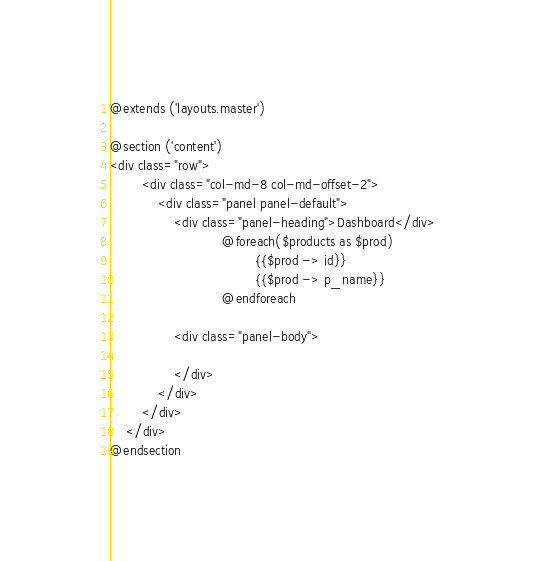Convert code to text. <code><loc_0><loc_0><loc_500><loc_500><_PHP_>@extends ('layouts.master')

@section ('content')
<div class="row">
        <div class="col-md-8 col-md-offset-2">
            <div class="panel panel-default">
                <div class="panel-heading">Dashboard</div>
							@foreach($products as $prod)
									{{$prod -> id}}
                                    {{$prod -> p_name}}
							@endforeach

	        	<div class="panel-body">
               
                </div>
            </div>
        </div>
    </div>
@endsection</code> 